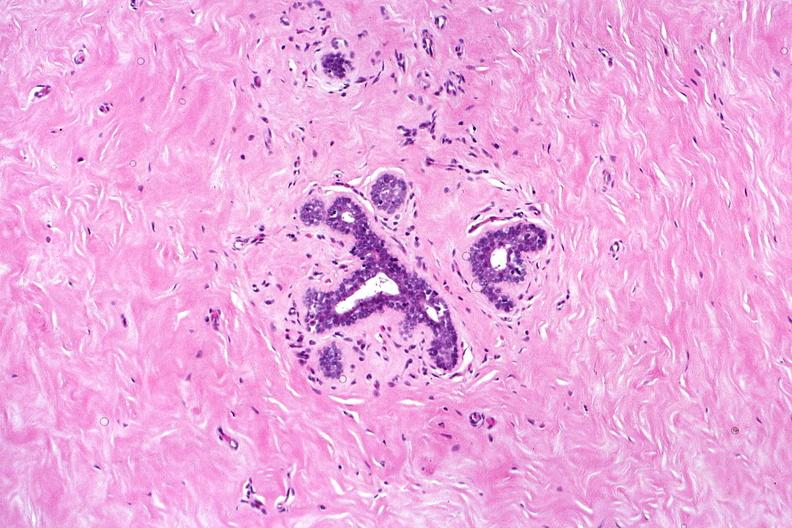what does this image show?
Answer the question using a single word or phrase. Normal breast 